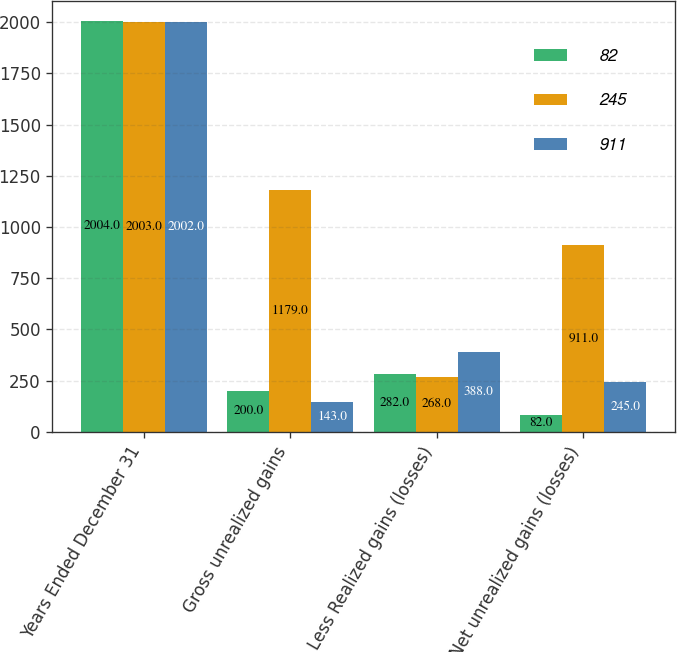Convert chart. <chart><loc_0><loc_0><loc_500><loc_500><stacked_bar_chart><ecel><fcel>Years Ended December 31<fcel>Gross unrealized gains<fcel>Less Realized gains (losses)<fcel>Net unrealized gains (losses)<nl><fcel>82<fcel>2004<fcel>200<fcel>282<fcel>82<nl><fcel>245<fcel>2003<fcel>1179<fcel>268<fcel>911<nl><fcel>911<fcel>2002<fcel>143<fcel>388<fcel>245<nl></chart> 